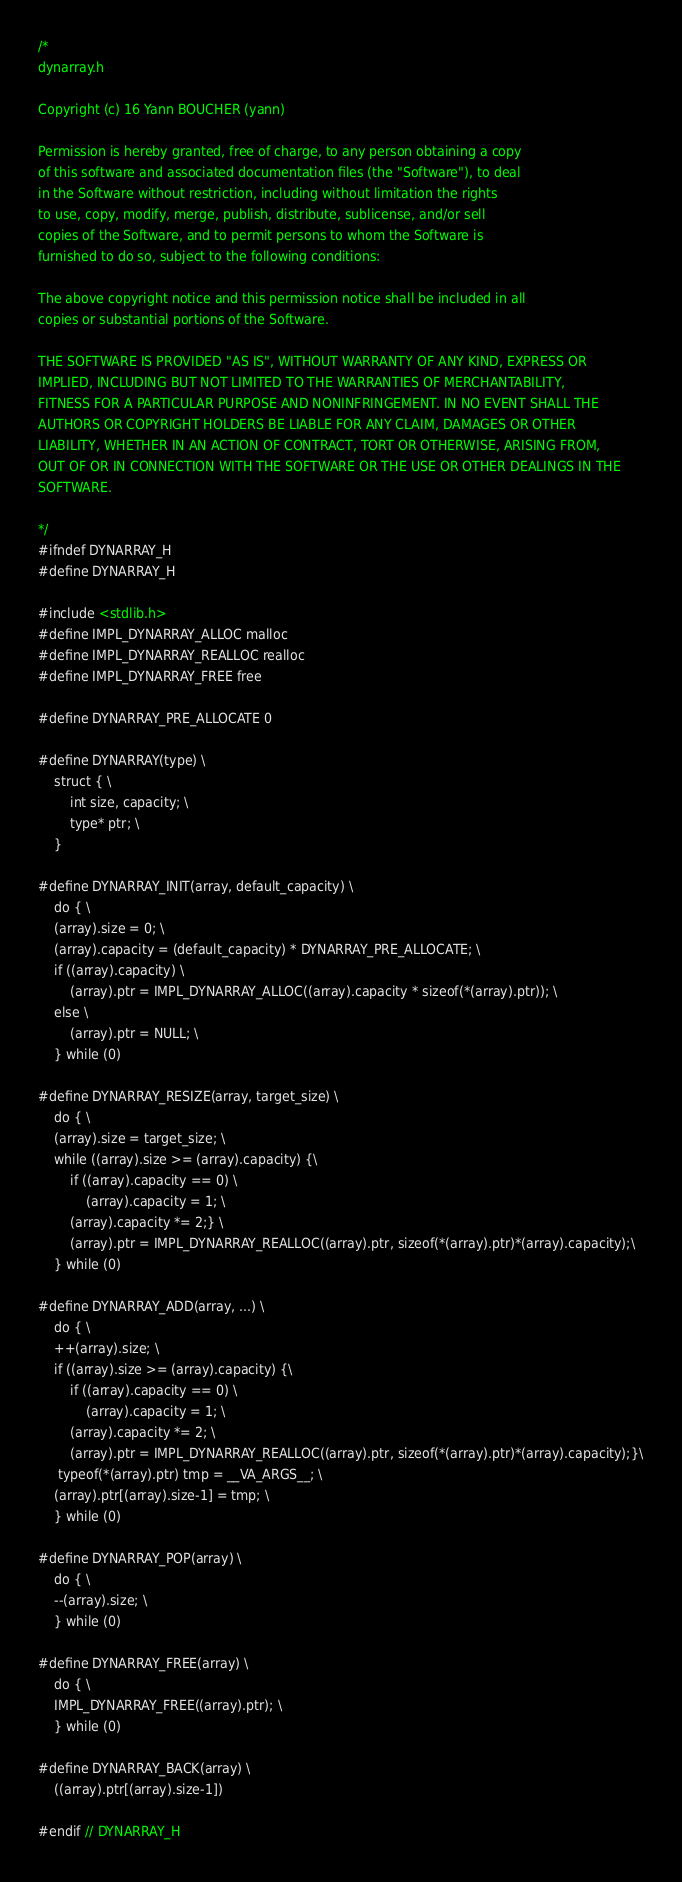<code> <loc_0><loc_0><loc_500><loc_500><_C_>/*
dynarray.h

Copyright (c) 16 Yann BOUCHER (yann)

Permission is hereby granted, free of charge, to any person obtaining a copy
of this software and associated documentation files (the "Software"), to deal
in the Software without restriction, including without limitation the rights
to use, copy, modify, merge, publish, distribute, sublicense, and/or sell
copies of the Software, and to permit persons to whom the Software is
furnished to do so, subject to the following conditions:

The above copyright notice and this permission notice shall be included in all
copies or substantial portions of the Software.

THE SOFTWARE IS PROVIDED "AS IS", WITHOUT WARRANTY OF ANY KIND, EXPRESS OR
IMPLIED, INCLUDING BUT NOT LIMITED TO THE WARRANTIES OF MERCHANTABILITY,
FITNESS FOR A PARTICULAR PURPOSE AND NONINFRINGEMENT. IN NO EVENT SHALL THE
AUTHORS OR COPYRIGHT HOLDERS BE LIABLE FOR ANY CLAIM, DAMAGES OR OTHER
LIABILITY, WHETHER IN AN ACTION OF CONTRACT, TORT OR OTHERWISE, ARISING FROM,
OUT OF OR IN CONNECTION WITH THE SOFTWARE OR THE USE OR OTHER DEALINGS IN THE
SOFTWARE.

*/
#ifndef DYNARRAY_H
#define DYNARRAY_H

#include <stdlib.h>
#define IMPL_DYNARRAY_ALLOC malloc
#define IMPL_DYNARRAY_REALLOC realloc
#define IMPL_DYNARRAY_FREE free

#define DYNARRAY_PRE_ALLOCATE 0

#define DYNARRAY(type) \
    struct { \
        int size, capacity; \
        type* ptr; \
    }

#define DYNARRAY_INIT(array, default_capacity) \
    do { \
    (array).size = 0; \
    (array).capacity = (default_capacity) * DYNARRAY_PRE_ALLOCATE; \
    if ((array).capacity) \
        (array).ptr = IMPL_DYNARRAY_ALLOC((array).capacity * sizeof(*(array).ptr)); \
    else \
        (array).ptr = NULL; \
    } while (0)

#define DYNARRAY_RESIZE(array, target_size) \
    do { \
    (array).size = target_size; \
    while ((array).size >= (array).capacity) {\
        if ((array).capacity == 0) \
            (array).capacity = 1; \
        (array).capacity *= 2;} \
        (array).ptr = IMPL_DYNARRAY_REALLOC((array).ptr, sizeof(*(array).ptr)*(array).capacity);\
    } while (0)

#define DYNARRAY_ADD(array, ...) \
    do { \
    ++(array).size; \
    if ((array).size >= (array).capacity) {\
        if ((array).capacity == 0) \
            (array).capacity = 1; \
        (array).capacity *= 2; \
        (array).ptr = IMPL_DYNARRAY_REALLOC((array).ptr, sizeof(*(array).ptr)*(array).capacity);}\
     typeof(*(array).ptr) tmp = __VA_ARGS__; \
    (array).ptr[(array).size-1] = tmp; \
    } while (0)

#define DYNARRAY_POP(array) \
    do { \
    --(array).size; \
    } while (0)

#define DYNARRAY_FREE(array) \
    do { \
    IMPL_DYNARRAY_FREE((array).ptr); \
    } while (0)

#define DYNARRAY_BACK(array) \
    ((array).ptr[(array).size-1])

#endif // DYNARRAY_H
</code> 